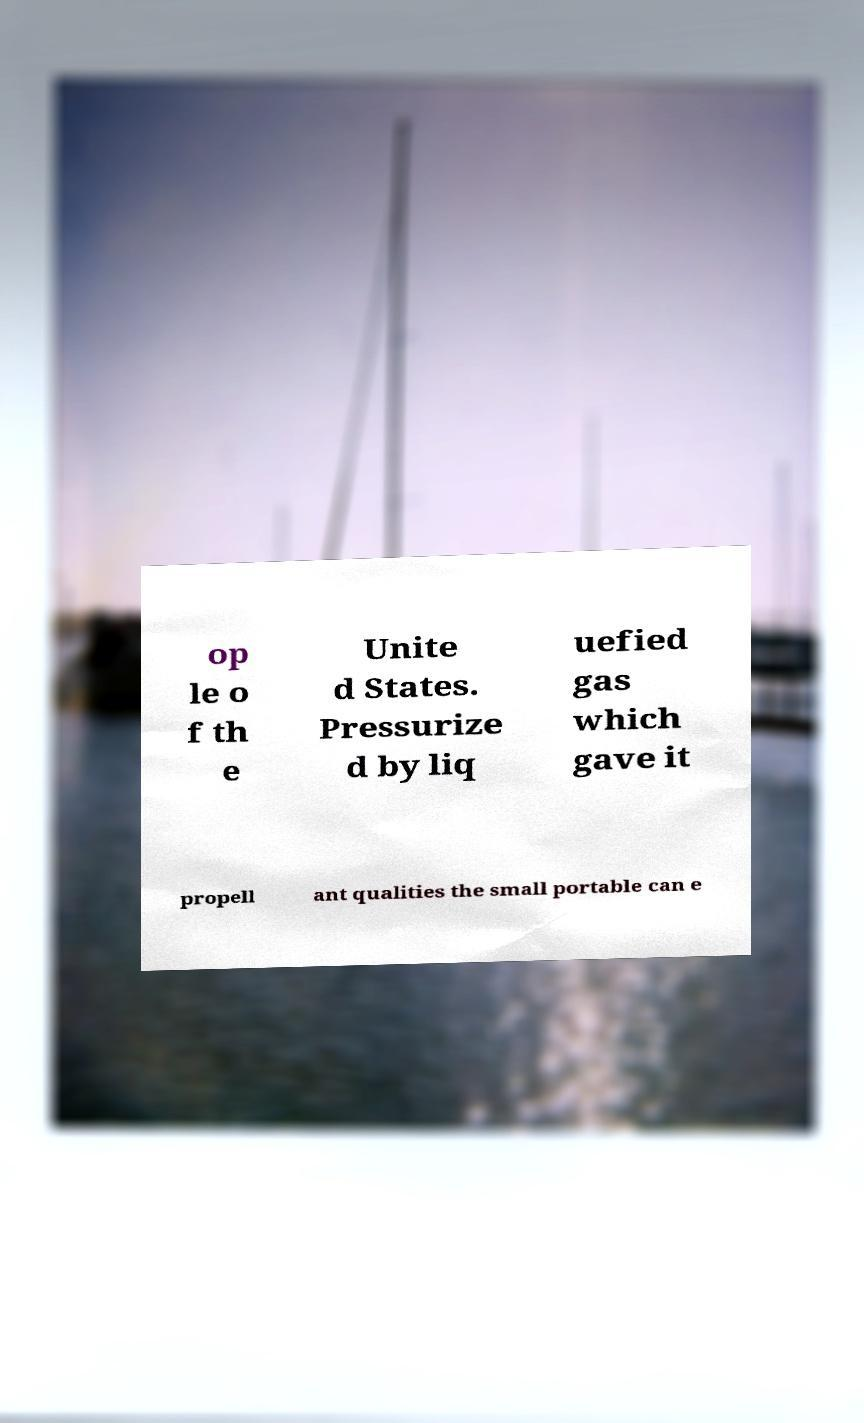Can you accurately transcribe the text from the provided image for me? op le o f th e Unite d States. Pressurize d by liq uefied gas which gave it propell ant qualities the small portable can e 